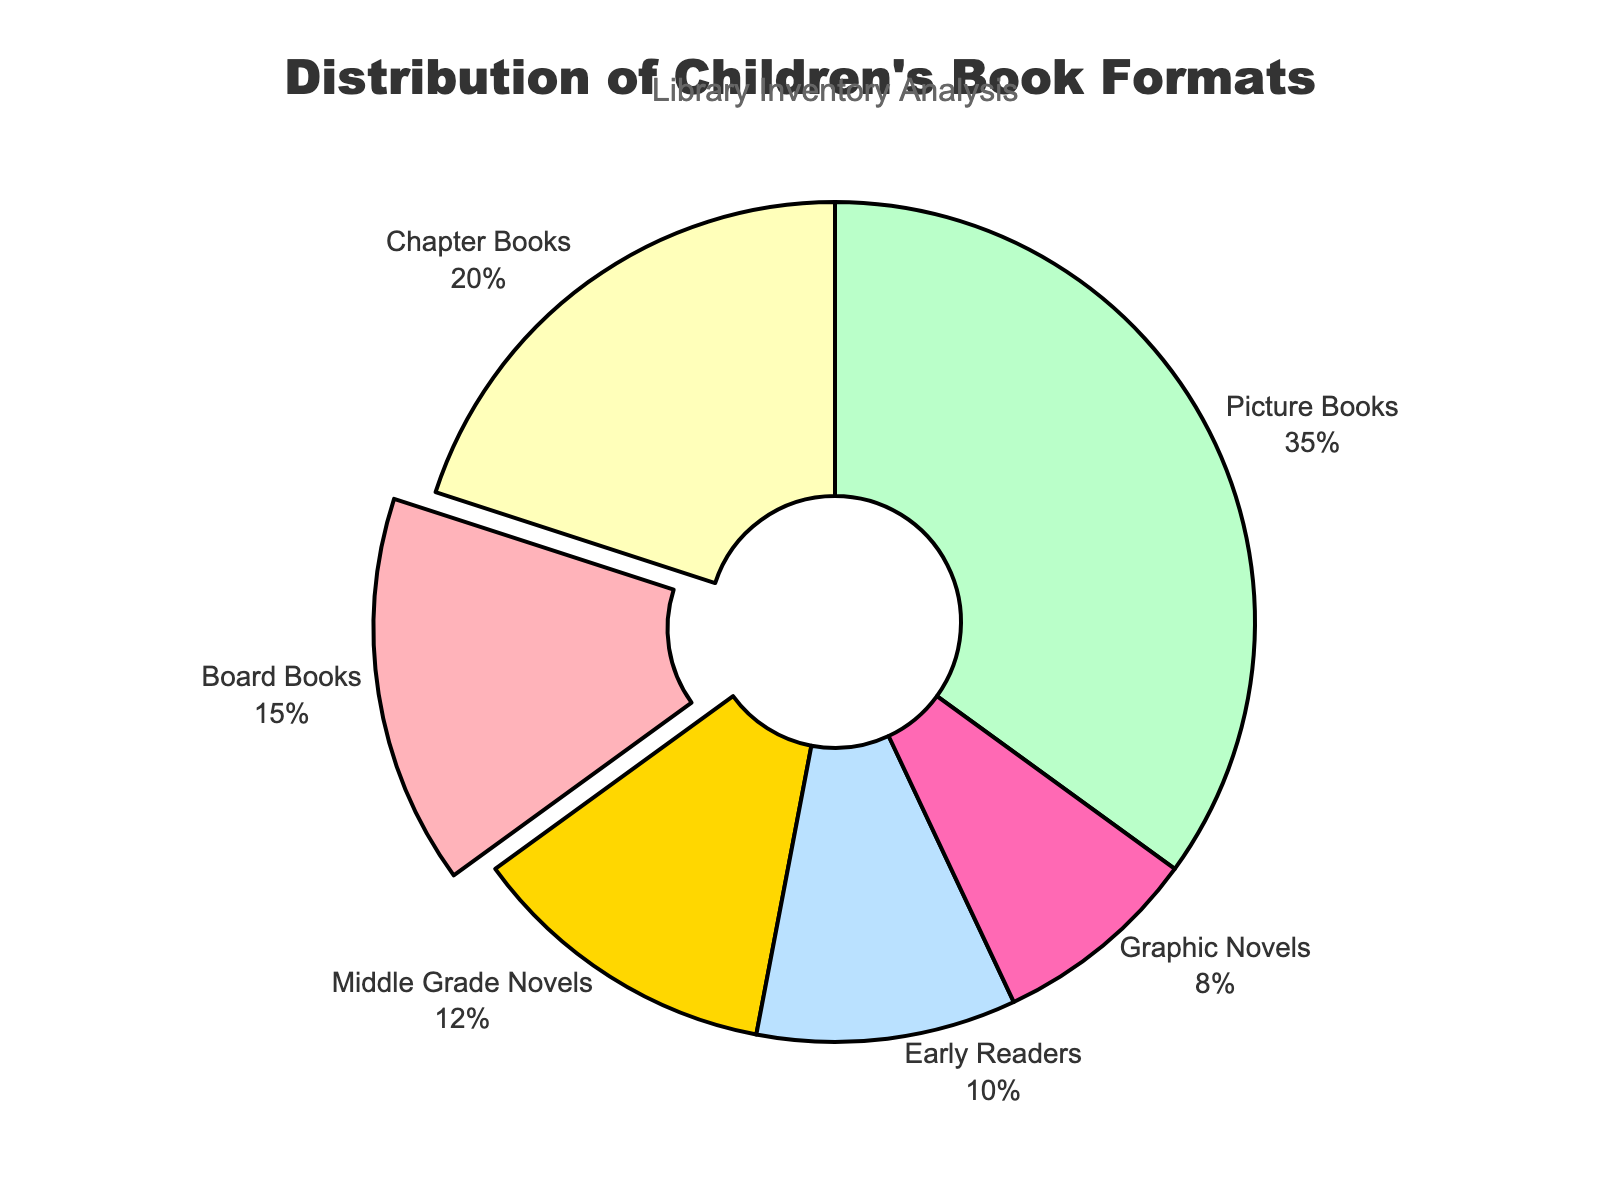How many types of children's book formats are displayed in the pie chart? There are distinct segments each representing a type of book format. Count the different labels to find the total.
Answer: 6 What percentage of the library's inventory is made up of picture books? Look at the segment labeled "Picture Books" on the chart. Note its associated percentage.
Answer: 35% What is the combined percentage of board books and early readers in the library's inventory? Locate the segments labeled "Board Books" and "Early Readers." Add their percentages: 15% + 10%.
Answer: 25% Which format has the smallest share in the library's inventory? Identify the segment with the smallest percentage value.
Answer: Graphic Novels What is the difference in percentage between picture books and chapter books? Locate the segments for "Picture Books" and "Chapter Books." Subtract the percentage of "Chapter Books" from "Picture Books": 35% - 20%.
Answer: 15% Is the percentage of middle-grade novels greater than that of early readers? Compare the percentages for "Middle Grade Novels" and "Early Readers": 12% and 10%, respectively.
Answer: Yes Which book format pulls away slightly from the rest in the pie chart? Identify the segment with a slight distance from the center. This is typically noted by visual separation.
Answer: Board Books What is the total percentage of chapter books and graphic novels combined? Locate the segments for "Chapter Books" and "Graphic Novels." Add their percentages: 20% + 8%.
Answer: 28% How many formats have a percentage greater than 10%? Count the segments with percentages greater than 10%.
Answer: 4 